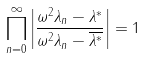Convert formula to latex. <formula><loc_0><loc_0><loc_500><loc_500>\prod _ { n = 0 } ^ { \infty } \left | \frac { \omega ^ { 2 } \lambda _ { n } - \lambda ^ { * } } { \omega ^ { 2 } \lambda _ { n } - \overline { \lambda ^ { * } } } \right | = 1</formula> 